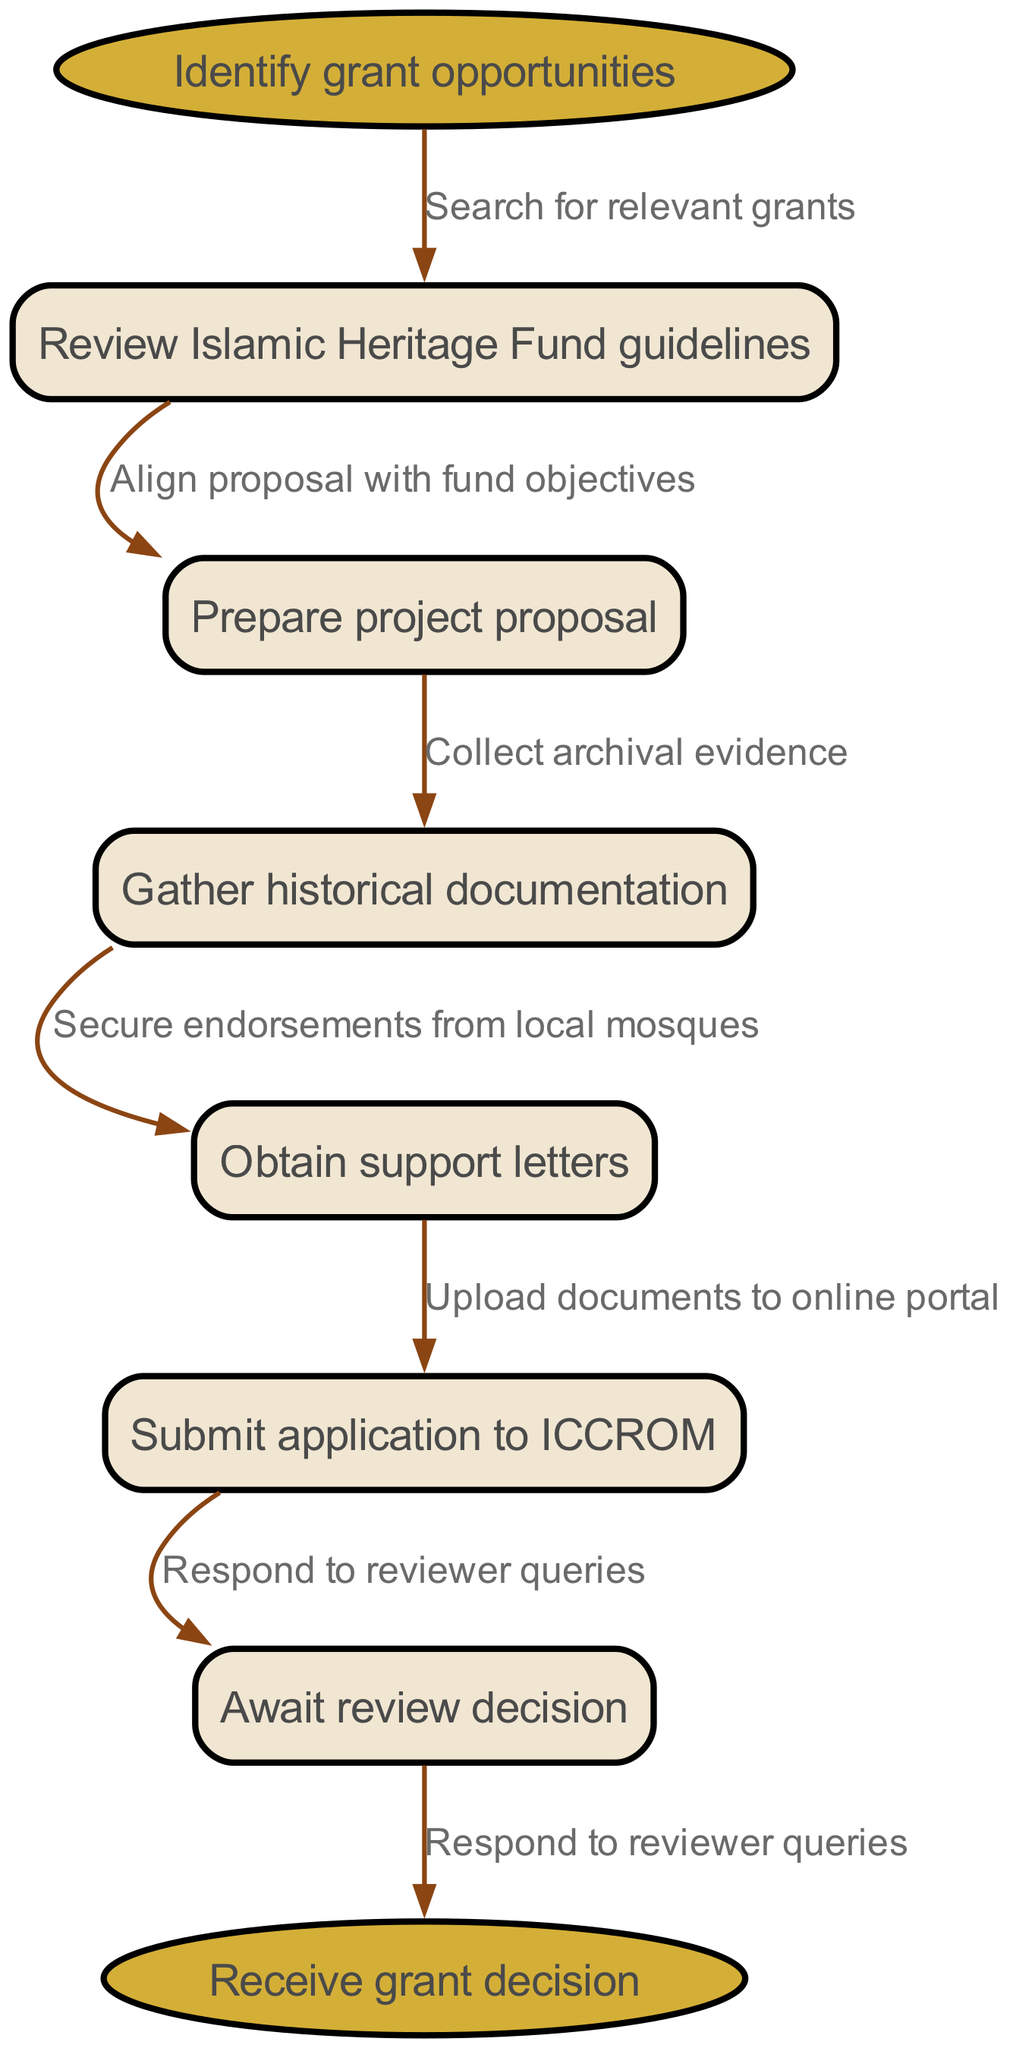What is the starting point of the flowchart? The starting node is labeled "Identify grant opportunities," which indicates the initial step in the grant application process.
Answer: Identify grant opportunities How many nodes are present in the flowchart? There are six intermediate nodes plus the start and end nodes, totaling eight nodes in the flowchart.
Answer: 8 Which node comes after "Prepare project proposal"? The node that directly follows "Prepare project proposal" is "Gather historical documentation," indicating the next step in the process.
Answer: Gather historical documentation What is the last step before receiving a grant decision? The last action before the endpoint is "Respond to reviewer queries," which implies that applicants must address any questions before a decision is made.
Answer: Respond to reviewer queries What action must be taken after "Obtain support letters"? The action that follows is "Submit application to ICCROM," showing the transition from gathering support to officially submitting the application.
Answer: Submit application to ICCROM Which node represents the need for collecting evidence? The node "Gather historical documentation" highlights the need for collecting archival evidence, crucial for substantiating the grant application.
Answer: Gather historical documentation What does the edge labeled "Align proposal with fund objectives" signify? This edge indicates that after reviewing the fund guidelines, applicants must ensure their project proposal aligns with the objectives of the fund, which is an essential part of the application process.
Answer: Align proposal with fund objectives What is the purpose of the node "Await review decision"? This node represents the period during which applicants must wait for the funding body's assessment of their application before a decision is rendered.
Answer: Await review decision What is indicated by the end node of the flowchart? The end node, "Receive grant decision," indicates the final outcome of the grant application process, summarizing the overall objective of following the steps outlined.
Answer: Receive grant decision 